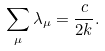<formula> <loc_0><loc_0><loc_500><loc_500>\sum _ { \mu } \lambda _ { \mu } = \frac { c } { 2 k } .</formula> 